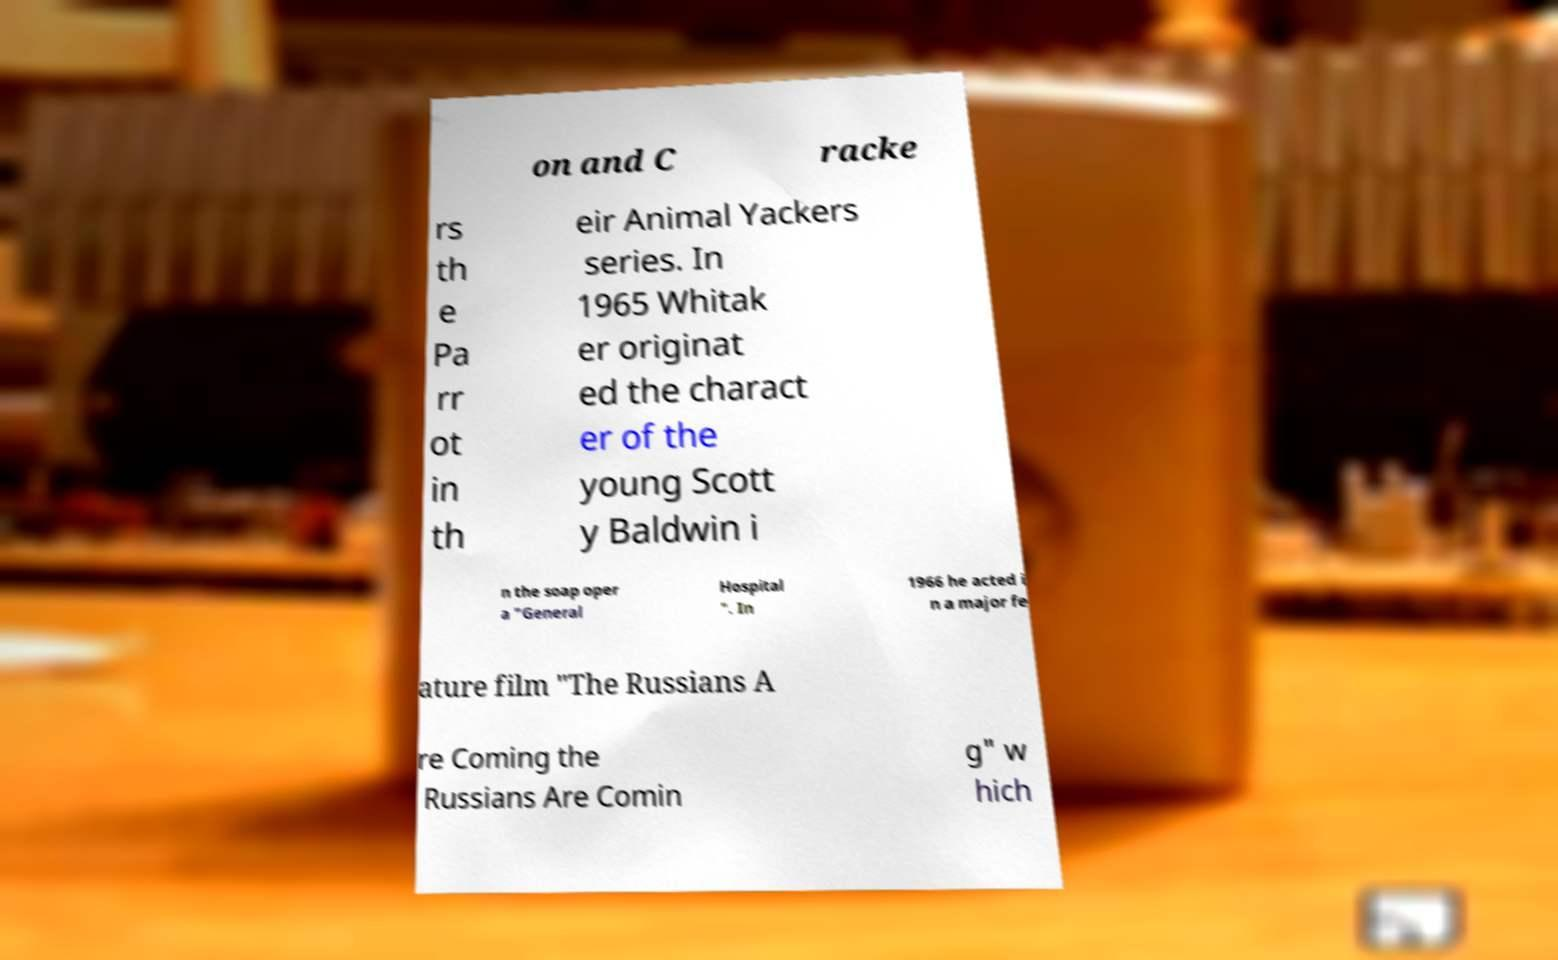Can you read and provide the text displayed in the image?This photo seems to have some interesting text. Can you extract and type it out for me? on and C racke rs th e Pa rr ot in th eir Animal Yackers series. In 1965 Whitak er originat ed the charact er of the young Scott y Baldwin i n the soap oper a "General Hospital ". In 1966 he acted i n a major fe ature film "The Russians A re Coming the Russians Are Comin g" w hich 